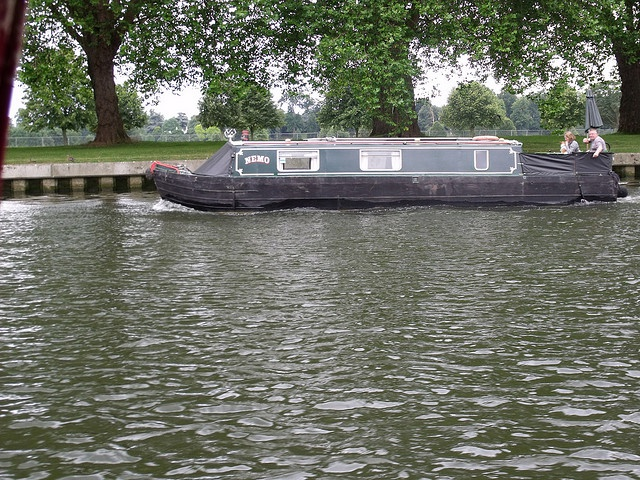Describe the objects in this image and their specific colors. I can see boat in maroon, gray, darkgray, black, and lightgray tones, umbrella in maroon, gray, and black tones, people in maroon, lavender, darkgray, gray, and lightpink tones, people in maroon, lavender, darkgray, and gray tones, and people in maroon, lightgray, tan, and gray tones in this image. 